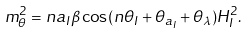<formula> <loc_0><loc_0><loc_500><loc_500>m _ { \theta } ^ { 2 } = n a _ { I } \beta \cos ( n \theta _ { I } + \theta _ { a _ { I } } + \theta _ { \lambda } ) H _ { I } ^ { 2 } .</formula> 